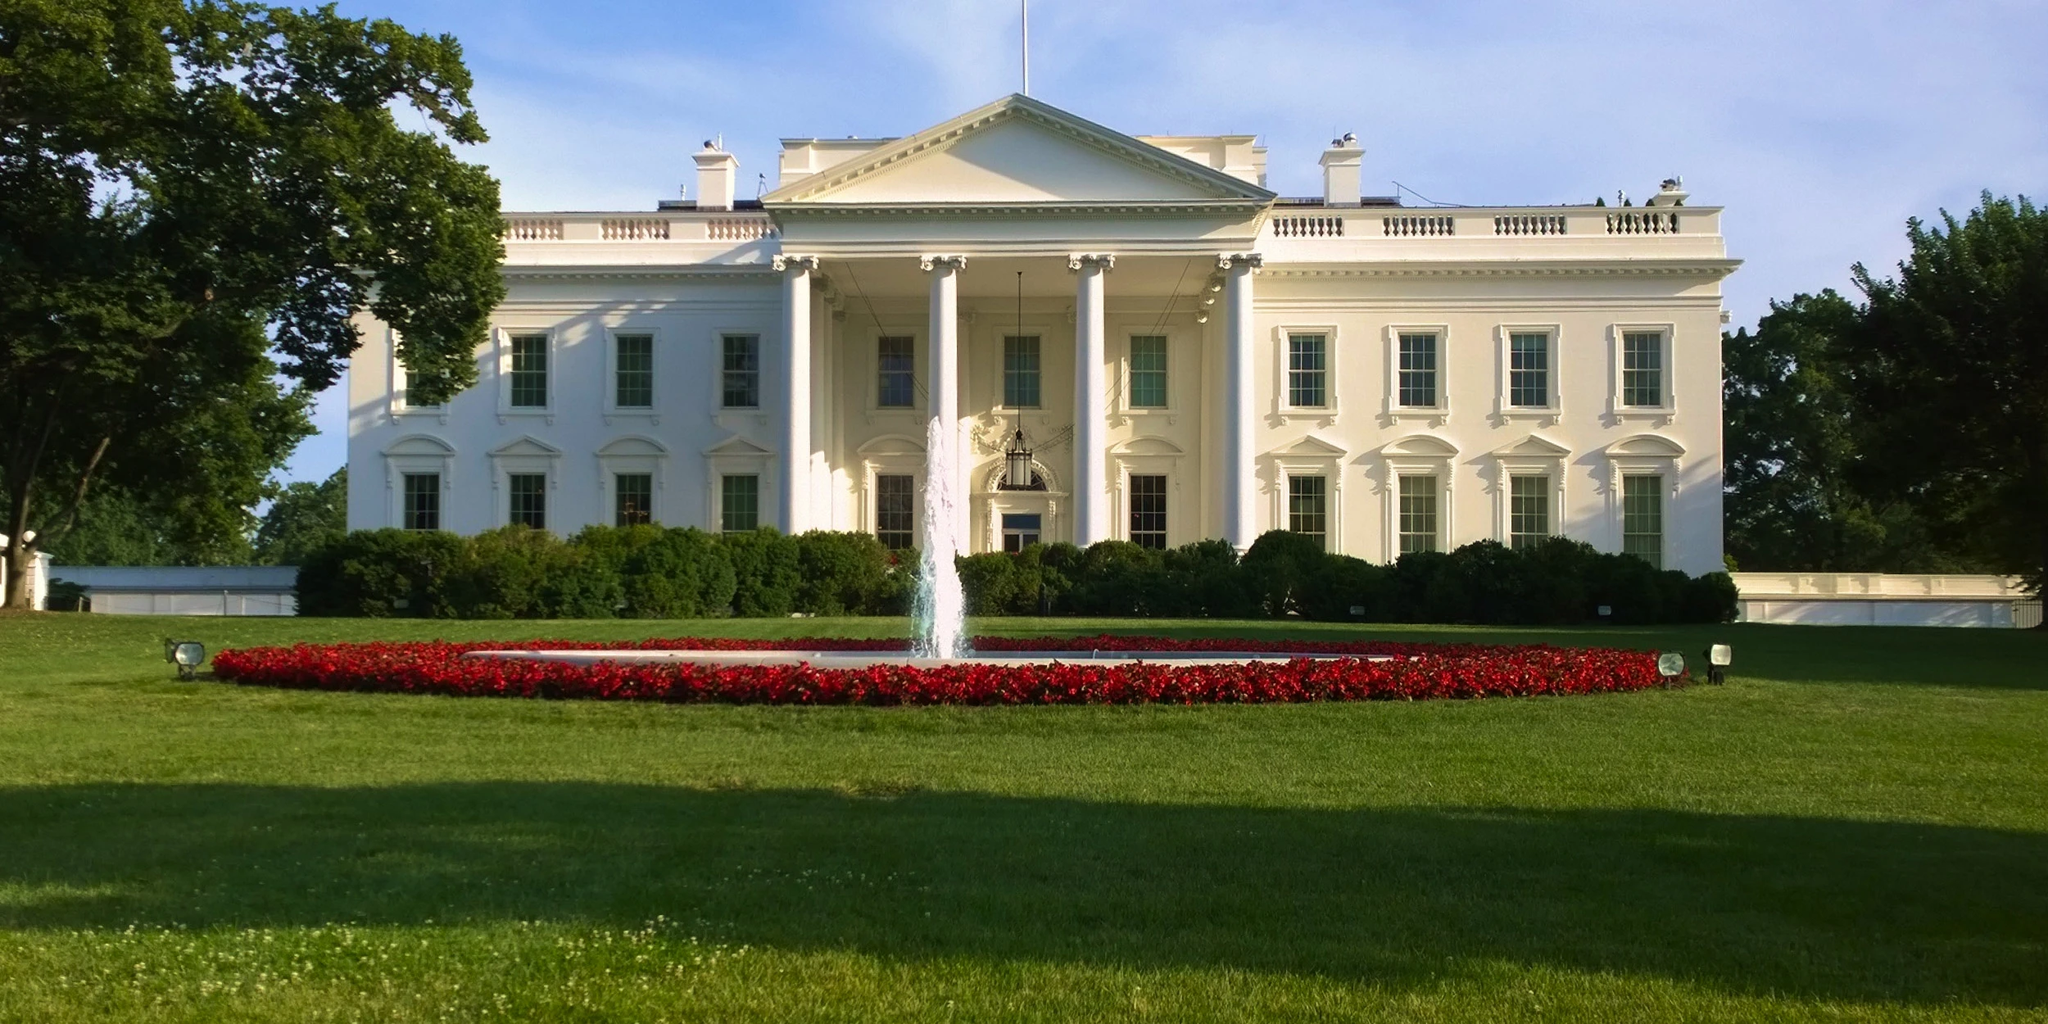Can you describe a realistic scenario involving a high-profile event on the White House lawn? Sure! Imagine a state dinner hosted on the White House lawn on a beautiful summer evening. The lawn is elegantly decorated with string lights, sophisticated seating arrangements, and a grand stage for live performances. The event is attended by various dignitaries, world leaders, and celebrities, creating an atmosphere of prestige and celebration. Guests mingle and engage in diplomatic discussions, all while enjoying gourmet cuisine prepared by renowned chefs. As the evening progresses, speeches are made, and the fountain's serene ambiance complements the elegant and formal tone of the event. 